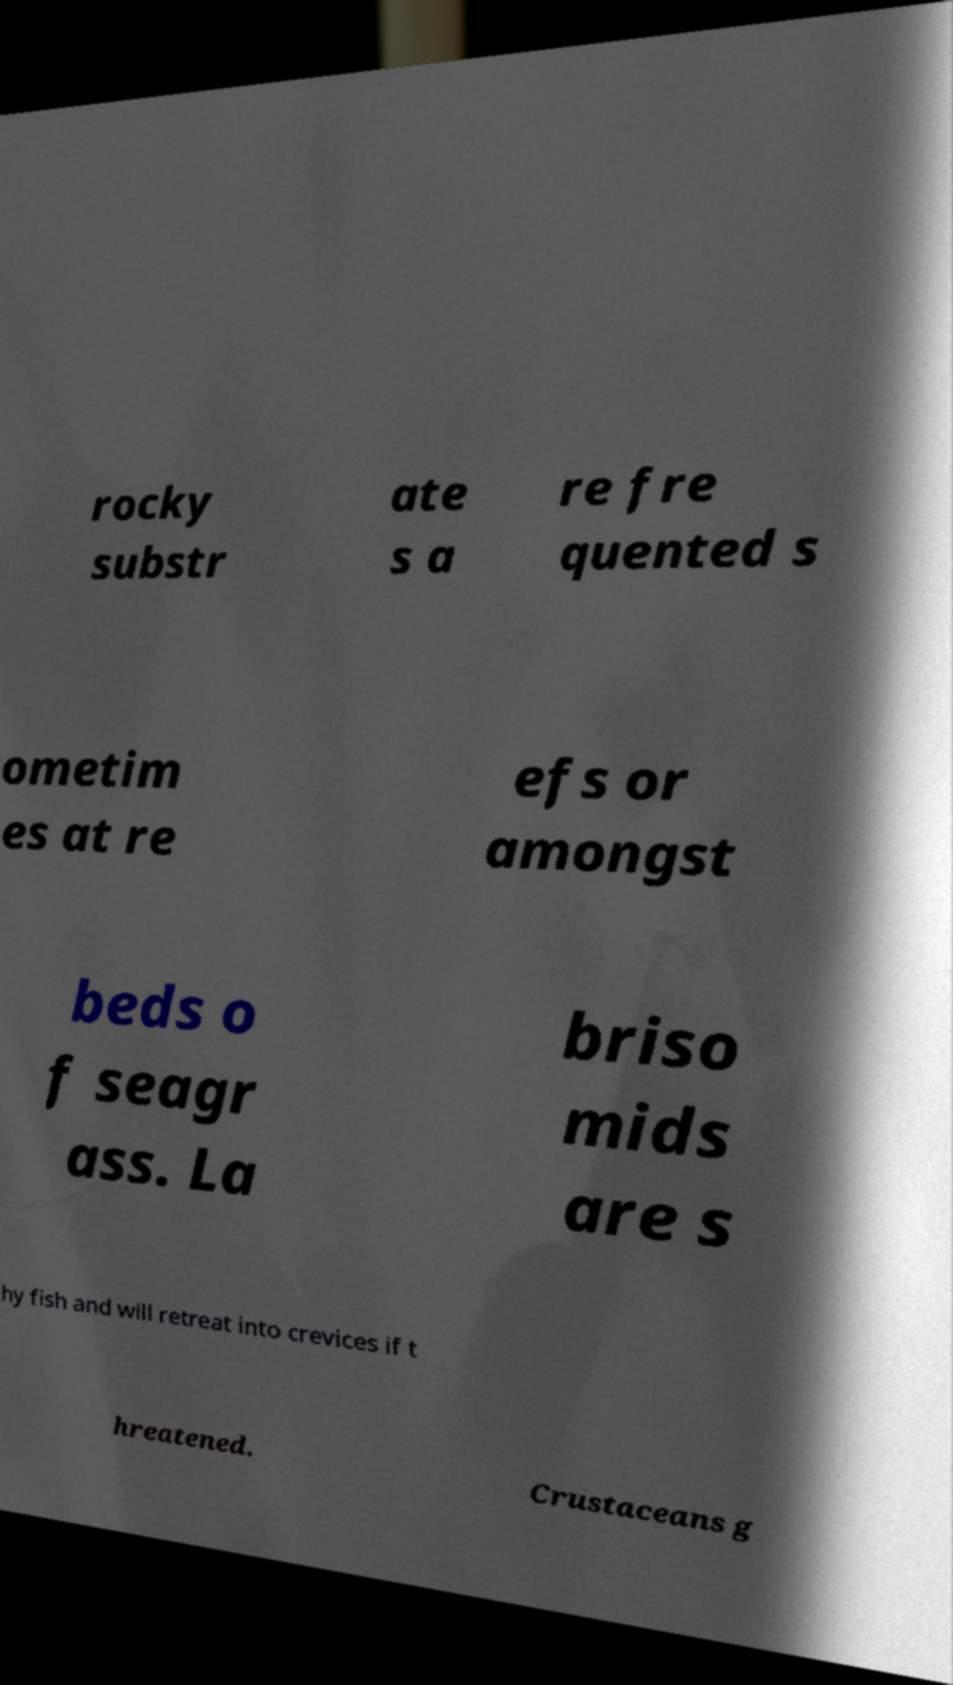Can you accurately transcribe the text from the provided image for me? rocky substr ate s a re fre quented s ometim es at re efs or amongst beds o f seagr ass. La briso mids are s hy fish and will retreat into crevices if t hreatened. Crustaceans g 